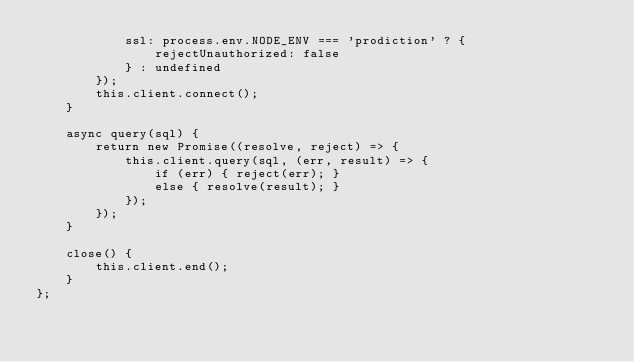<code> <loc_0><loc_0><loc_500><loc_500><_JavaScript_>            ssl: process.env.NODE_ENV === 'prodiction' ? {
                rejectUnauthorized: false
            } : undefined
        });
        this.client.connect();
    }

    async query(sql) {
        return new Promise((resolve, reject) => {
            this.client.query(sql, (err, result) => {
                if (err) { reject(err); }
                else { resolve(result); }
            });
        });
    }

    close() {
        this.client.end();
    }
};</code> 